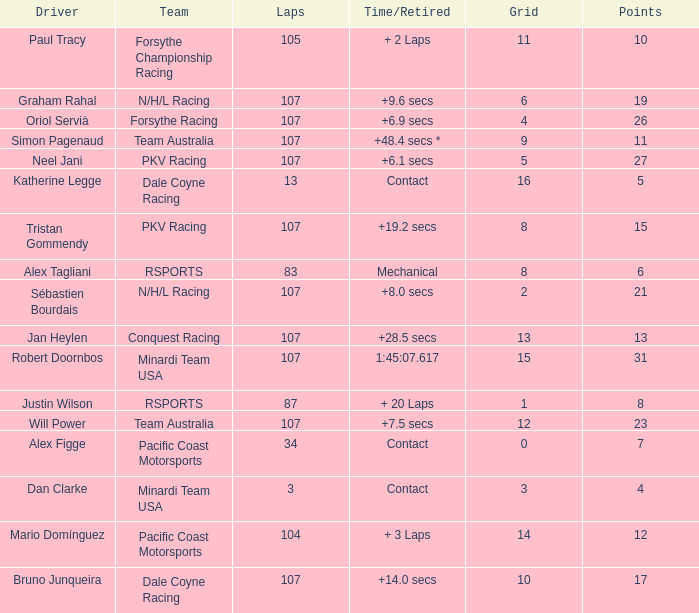What is mario domínguez's average Grid? 14.0. Would you be able to parse every entry in this table? {'header': ['Driver', 'Team', 'Laps', 'Time/Retired', 'Grid', 'Points'], 'rows': [['Paul Tracy', 'Forsythe Championship Racing', '105', '+ 2 Laps', '11', '10'], ['Graham Rahal', 'N/H/L Racing', '107', '+9.6 secs', '6', '19'], ['Oriol Servià', 'Forsythe Racing', '107', '+6.9 secs', '4', '26'], ['Simon Pagenaud', 'Team Australia', '107', '+48.4 secs *', '9', '11'], ['Neel Jani', 'PKV Racing', '107', '+6.1 secs', '5', '27'], ['Katherine Legge', 'Dale Coyne Racing', '13', 'Contact', '16', '5'], ['Tristan Gommendy', 'PKV Racing', '107', '+19.2 secs', '8', '15'], ['Alex Tagliani', 'RSPORTS', '83', 'Mechanical', '8', '6'], ['Sébastien Bourdais', 'N/H/L Racing', '107', '+8.0 secs', '2', '21'], ['Jan Heylen', 'Conquest Racing', '107', '+28.5 secs', '13', '13'], ['Robert Doornbos', 'Minardi Team USA', '107', '1:45:07.617', '15', '31'], ['Justin Wilson', 'RSPORTS', '87', '+ 20 Laps', '1', '8'], ['Will Power', 'Team Australia', '107', '+7.5 secs', '12', '23'], ['Alex Figge', 'Pacific Coast Motorsports', '34', 'Contact', '0', '7'], ['Dan Clarke', 'Minardi Team USA', '3', 'Contact', '3', '4'], ['Mario Domínguez', 'Pacific Coast Motorsports', '104', '+ 3 Laps', '14', '12'], ['Bruno Junqueira', 'Dale Coyne Racing', '107', '+14.0 secs', '10', '17']]} 